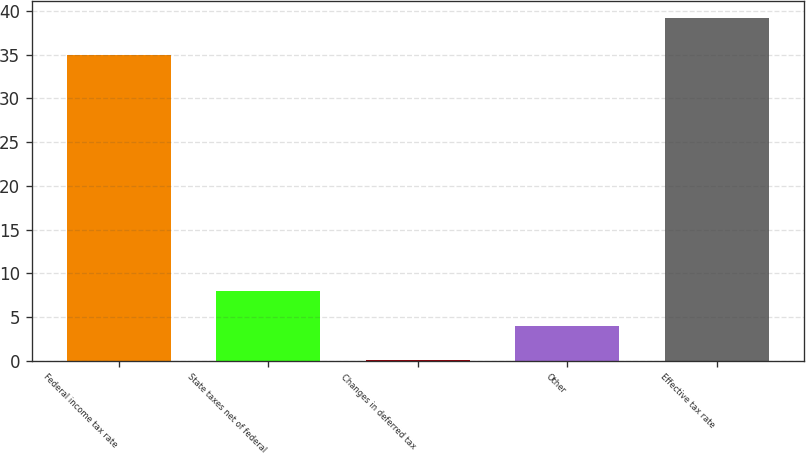Convert chart. <chart><loc_0><loc_0><loc_500><loc_500><bar_chart><fcel>Federal income tax rate<fcel>State taxes net of federal<fcel>Changes in deferred tax<fcel>Other<fcel>Effective tax rate<nl><fcel>35<fcel>7.92<fcel>0.1<fcel>4.01<fcel>39.2<nl></chart> 